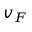<formula> <loc_0><loc_0><loc_500><loc_500>v _ { F }</formula> 